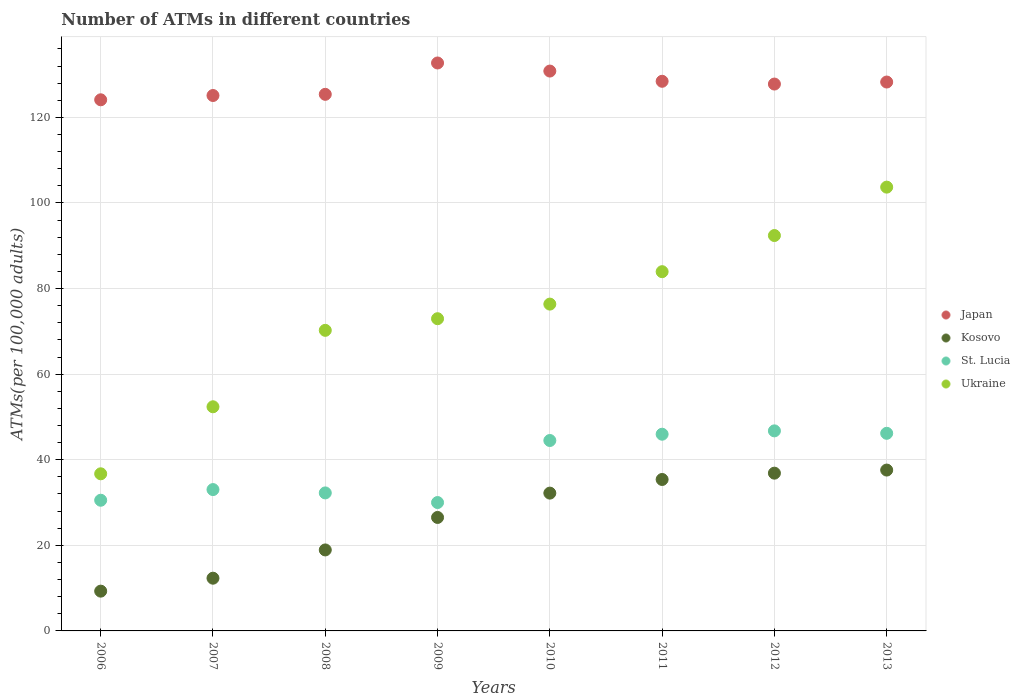How many different coloured dotlines are there?
Offer a very short reply. 4. What is the number of ATMs in Ukraine in 2009?
Provide a succinct answer. 72.96. Across all years, what is the maximum number of ATMs in St. Lucia?
Your answer should be very brief. 46.75. Across all years, what is the minimum number of ATMs in Kosovo?
Your answer should be very brief. 9.29. In which year was the number of ATMs in Kosovo minimum?
Ensure brevity in your answer.  2006. What is the total number of ATMs in Kosovo in the graph?
Your answer should be very brief. 209.1. What is the difference between the number of ATMs in Japan in 2010 and that in 2013?
Provide a short and direct response. 2.56. What is the difference between the number of ATMs in Ukraine in 2006 and the number of ATMs in Kosovo in 2010?
Keep it short and to the point. 4.51. What is the average number of ATMs in St. Lucia per year?
Keep it short and to the point. 38.65. In the year 2006, what is the difference between the number of ATMs in Kosovo and number of ATMs in Japan?
Your answer should be very brief. -114.82. What is the ratio of the number of ATMs in Japan in 2006 to that in 2010?
Provide a short and direct response. 0.95. Is the number of ATMs in Japan in 2008 less than that in 2013?
Ensure brevity in your answer.  Yes. What is the difference between the highest and the second highest number of ATMs in St. Lucia?
Keep it short and to the point. 0.57. What is the difference between the highest and the lowest number of ATMs in Japan?
Give a very brief answer. 8.6. Is the number of ATMs in Ukraine strictly greater than the number of ATMs in Kosovo over the years?
Your response must be concise. Yes. Is the number of ATMs in St. Lucia strictly less than the number of ATMs in Kosovo over the years?
Offer a very short reply. No. What is the difference between two consecutive major ticks on the Y-axis?
Provide a short and direct response. 20. Does the graph contain grids?
Provide a succinct answer. Yes. How many legend labels are there?
Offer a terse response. 4. What is the title of the graph?
Give a very brief answer. Number of ATMs in different countries. Does "Albania" appear as one of the legend labels in the graph?
Make the answer very short. No. What is the label or title of the X-axis?
Give a very brief answer. Years. What is the label or title of the Y-axis?
Offer a very short reply. ATMs(per 100,0 adults). What is the ATMs(per 100,000 adults) of Japan in 2006?
Provide a short and direct response. 124.11. What is the ATMs(per 100,000 adults) in Kosovo in 2006?
Make the answer very short. 9.29. What is the ATMs(per 100,000 adults) in St. Lucia in 2006?
Your answer should be very brief. 30.54. What is the ATMs(per 100,000 adults) of Ukraine in 2006?
Offer a terse response. 36.72. What is the ATMs(per 100,000 adults) of Japan in 2007?
Make the answer very short. 125.11. What is the ATMs(per 100,000 adults) of Kosovo in 2007?
Your response must be concise. 12.32. What is the ATMs(per 100,000 adults) of St. Lucia in 2007?
Keep it short and to the point. 33.03. What is the ATMs(per 100,000 adults) of Ukraine in 2007?
Ensure brevity in your answer.  52.38. What is the ATMs(per 100,000 adults) in Japan in 2008?
Provide a succinct answer. 125.39. What is the ATMs(per 100,000 adults) in Kosovo in 2008?
Your answer should be compact. 18.92. What is the ATMs(per 100,000 adults) in St. Lucia in 2008?
Your response must be concise. 32.25. What is the ATMs(per 100,000 adults) of Ukraine in 2008?
Make the answer very short. 70.24. What is the ATMs(per 100,000 adults) in Japan in 2009?
Your answer should be very brief. 132.71. What is the ATMs(per 100,000 adults) of Kosovo in 2009?
Provide a short and direct response. 26.52. What is the ATMs(per 100,000 adults) in St. Lucia in 2009?
Provide a succinct answer. 30. What is the ATMs(per 100,000 adults) of Ukraine in 2009?
Your answer should be very brief. 72.96. What is the ATMs(per 100,000 adults) in Japan in 2010?
Make the answer very short. 130.82. What is the ATMs(per 100,000 adults) of Kosovo in 2010?
Provide a short and direct response. 32.2. What is the ATMs(per 100,000 adults) of St. Lucia in 2010?
Your response must be concise. 44.5. What is the ATMs(per 100,000 adults) of Ukraine in 2010?
Your answer should be very brief. 76.37. What is the ATMs(per 100,000 adults) of Japan in 2011?
Make the answer very short. 128.44. What is the ATMs(per 100,000 adults) in Kosovo in 2011?
Offer a terse response. 35.39. What is the ATMs(per 100,000 adults) of St. Lucia in 2011?
Your answer should be compact. 45.96. What is the ATMs(per 100,000 adults) of Ukraine in 2011?
Offer a terse response. 83.95. What is the ATMs(per 100,000 adults) in Japan in 2012?
Keep it short and to the point. 127.79. What is the ATMs(per 100,000 adults) of Kosovo in 2012?
Provide a short and direct response. 36.86. What is the ATMs(per 100,000 adults) of St. Lucia in 2012?
Offer a terse response. 46.75. What is the ATMs(per 100,000 adults) of Ukraine in 2012?
Make the answer very short. 92.39. What is the ATMs(per 100,000 adults) in Japan in 2013?
Your answer should be compact. 128.26. What is the ATMs(per 100,000 adults) in Kosovo in 2013?
Ensure brevity in your answer.  37.59. What is the ATMs(per 100,000 adults) in St. Lucia in 2013?
Offer a very short reply. 46.18. What is the ATMs(per 100,000 adults) in Ukraine in 2013?
Your answer should be compact. 103.7. Across all years, what is the maximum ATMs(per 100,000 adults) in Japan?
Offer a terse response. 132.71. Across all years, what is the maximum ATMs(per 100,000 adults) of Kosovo?
Offer a very short reply. 37.59. Across all years, what is the maximum ATMs(per 100,000 adults) in St. Lucia?
Offer a very short reply. 46.75. Across all years, what is the maximum ATMs(per 100,000 adults) in Ukraine?
Offer a very short reply. 103.7. Across all years, what is the minimum ATMs(per 100,000 adults) of Japan?
Ensure brevity in your answer.  124.11. Across all years, what is the minimum ATMs(per 100,000 adults) in Kosovo?
Provide a short and direct response. 9.29. Across all years, what is the minimum ATMs(per 100,000 adults) in St. Lucia?
Keep it short and to the point. 30. Across all years, what is the minimum ATMs(per 100,000 adults) in Ukraine?
Your response must be concise. 36.72. What is the total ATMs(per 100,000 adults) of Japan in the graph?
Give a very brief answer. 1022.63. What is the total ATMs(per 100,000 adults) in Kosovo in the graph?
Keep it short and to the point. 209.1. What is the total ATMs(per 100,000 adults) of St. Lucia in the graph?
Give a very brief answer. 309.2. What is the total ATMs(per 100,000 adults) of Ukraine in the graph?
Make the answer very short. 588.7. What is the difference between the ATMs(per 100,000 adults) of Japan in 2006 and that in 2007?
Keep it short and to the point. -1. What is the difference between the ATMs(per 100,000 adults) of Kosovo in 2006 and that in 2007?
Offer a very short reply. -3.03. What is the difference between the ATMs(per 100,000 adults) of St. Lucia in 2006 and that in 2007?
Provide a succinct answer. -2.49. What is the difference between the ATMs(per 100,000 adults) of Ukraine in 2006 and that in 2007?
Your answer should be compact. -15.66. What is the difference between the ATMs(per 100,000 adults) of Japan in 2006 and that in 2008?
Offer a very short reply. -1.28. What is the difference between the ATMs(per 100,000 adults) of Kosovo in 2006 and that in 2008?
Your answer should be very brief. -9.63. What is the difference between the ATMs(per 100,000 adults) of St. Lucia in 2006 and that in 2008?
Give a very brief answer. -1.71. What is the difference between the ATMs(per 100,000 adults) of Ukraine in 2006 and that in 2008?
Provide a succinct answer. -33.52. What is the difference between the ATMs(per 100,000 adults) in Japan in 2006 and that in 2009?
Make the answer very short. -8.6. What is the difference between the ATMs(per 100,000 adults) in Kosovo in 2006 and that in 2009?
Your answer should be compact. -17.22. What is the difference between the ATMs(per 100,000 adults) of St. Lucia in 2006 and that in 2009?
Your answer should be very brief. 0.54. What is the difference between the ATMs(per 100,000 adults) of Ukraine in 2006 and that in 2009?
Your answer should be compact. -36.24. What is the difference between the ATMs(per 100,000 adults) of Japan in 2006 and that in 2010?
Offer a terse response. -6.71. What is the difference between the ATMs(per 100,000 adults) in Kosovo in 2006 and that in 2010?
Keep it short and to the point. -22.91. What is the difference between the ATMs(per 100,000 adults) of St. Lucia in 2006 and that in 2010?
Offer a terse response. -13.96. What is the difference between the ATMs(per 100,000 adults) in Ukraine in 2006 and that in 2010?
Provide a short and direct response. -39.65. What is the difference between the ATMs(per 100,000 adults) of Japan in 2006 and that in 2011?
Offer a very short reply. -4.33. What is the difference between the ATMs(per 100,000 adults) of Kosovo in 2006 and that in 2011?
Ensure brevity in your answer.  -26.09. What is the difference between the ATMs(per 100,000 adults) of St. Lucia in 2006 and that in 2011?
Give a very brief answer. -15.43. What is the difference between the ATMs(per 100,000 adults) in Ukraine in 2006 and that in 2011?
Offer a terse response. -47.23. What is the difference between the ATMs(per 100,000 adults) in Japan in 2006 and that in 2012?
Offer a terse response. -3.68. What is the difference between the ATMs(per 100,000 adults) of Kosovo in 2006 and that in 2012?
Your answer should be very brief. -27.57. What is the difference between the ATMs(per 100,000 adults) in St. Lucia in 2006 and that in 2012?
Provide a short and direct response. -16.21. What is the difference between the ATMs(per 100,000 adults) of Ukraine in 2006 and that in 2012?
Your answer should be very brief. -55.68. What is the difference between the ATMs(per 100,000 adults) of Japan in 2006 and that in 2013?
Give a very brief answer. -4.15. What is the difference between the ATMs(per 100,000 adults) in Kosovo in 2006 and that in 2013?
Your answer should be compact. -28.29. What is the difference between the ATMs(per 100,000 adults) in St. Lucia in 2006 and that in 2013?
Your answer should be very brief. -15.64. What is the difference between the ATMs(per 100,000 adults) of Ukraine in 2006 and that in 2013?
Your answer should be very brief. -66.99. What is the difference between the ATMs(per 100,000 adults) of Japan in 2007 and that in 2008?
Give a very brief answer. -0.28. What is the difference between the ATMs(per 100,000 adults) of Kosovo in 2007 and that in 2008?
Ensure brevity in your answer.  -6.6. What is the difference between the ATMs(per 100,000 adults) in St. Lucia in 2007 and that in 2008?
Offer a very short reply. 0.78. What is the difference between the ATMs(per 100,000 adults) in Ukraine in 2007 and that in 2008?
Your answer should be compact. -17.86. What is the difference between the ATMs(per 100,000 adults) of Japan in 2007 and that in 2009?
Your answer should be compact. -7.6. What is the difference between the ATMs(per 100,000 adults) of Kosovo in 2007 and that in 2009?
Your answer should be very brief. -14.2. What is the difference between the ATMs(per 100,000 adults) in St. Lucia in 2007 and that in 2009?
Make the answer very short. 3.03. What is the difference between the ATMs(per 100,000 adults) in Ukraine in 2007 and that in 2009?
Ensure brevity in your answer.  -20.58. What is the difference between the ATMs(per 100,000 adults) of Japan in 2007 and that in 2010?
Ensure brevity in your answer.  -5.71. What is the difference between the ATMs(per 100,000 adults) of Kosovo in 2007 and that in 2010?
Your answer should be very brief. -19.88. What is the difference between the ATMs(per 100,000 adults) in St. Lucia in 2007 and that in 2010?
Keep it short and to the point. -11.47. What is the difference between the ATMs(per 100,000 adults) in Ukraine in 2007 and that in 2010?
Give a very brief answer. -23.99. What is the difference between the ATMs(per 100,000 adults) in Japan in 2007 and that in 2011?
Ensure brevity in your answer.  -3.32. What is the difference between the ATMs(per 100,000 adults) in Kosovo in 2007 and that in 2011?
Your response must be concise. -23.07. What is the difference between the ATMs(per 100,000 adults) in St. Lucia in 2007 and that in 2011?
Give a very brief answer. -12.94. What is the difference between the ATMs(per 100,000 adults) in Ukraine in 2007 and that in 2011?
Offer a very short reply. -31.57. What is the difference between the ATMs(per 100,000 adults) of Japan in 2007 and that in 2012?
Your answer should be compact. -2.68. What is the difference between the ATMs(per 100,000 adults) of Kosovo in 2007 and that in 2012?
Offer a terse response. -24.54. What is the difference between the ATMs(per 100,000 adults) in St. Lucia in 2007 and that in 2012?
Offer a very short reply. -13.72. What is the difference between the ATMs(per 100,000 adults) in Ukraine in 2007 and that in 2012?
Keep it short and to the point. -40.02. What is the difference between the ATMs(per 100,000 adults) of Japan in 2007 and that in 2013?
Keep it short and to the point. -3.15. What is the difference between the ATMs(per 100,000 adults) in Kosovo in 2007 and that in 2013?
Your answer should be very brief. -25.27. What is the difference between the ATMs(per 100,000 adults) of St. Lucia in 2007 and that in 2013?
Your response must be concise. -13.15. What is the difference between the ATMs(per 100,000 adults) in Ukraine in 2007 and that in 2013?
Keep it short and to the point. -51.33. What is the difference between the ATMs(per 100,000 adults) of Japan in 2008 and that in 2009?
Provide a succinct answer. -7.32. What is the difference between the ATMs(per 100,000 adults) of Kosovo in 2008 and that in 2009?
Provide a short and direct response. -7.59. What is the difference between the ATMs(per 100,000 adults) in St. Lucia in 2008 and that in 2009?
Offer a terse response. 2.25. What is the difference between the ATMs(per 100,000 adults) of Ukraine in 2008 and that in 2009?
Keep it short and to the point. -2.72. What is the difference between the ATMs(per 100,000 adults) in Japan in 2008 and that in 2010?
Your answer should be compact. -5.44. What is the difference between the ATMs(per 100,000 adults) in Kosovo in 2008 and that in 2010?
Give a very brief answer. -13.28. What is the difference between the ATMs(per 100,000 adults) of St. Lucia in 2008 and that in 2010?
Give a very brief answer. -12.25. What is the difference between the ATMs(per 100,000 adults) of Ukraine in 2008 and that in 2010?
Give a very brief answer. -6.13. What is the difference between the ATMs(per 100,000 adults) of Japan in 2008 and that in 2011?
Your response must be concise. -3.05. What is the difference between the ATMs(per 100,000 adults) in Kosovo in 2008 and that in 2011?
Give a very brief answer. -16.46. What is the difference between the ATMs(per 100,000 adults) in St. Lucia in 2008 and that in 2011?
Provide a short and direct response. -13.72. What is the difference between the ATMs(per 100,000 adults) in Ukraine in 2008 and that in 2011?
Ensure brevity in your answer.  -13.71. What is the difference between the ATMs(per 100,000 adults) of Japan in 2008 and that in 2012?
Provide a succinct answer. -2.4. What is the difference between the ATMs(per 100,000 adults) of Kosovo in 2008 and that in 2012?
Your response must be concise. -17.94. What is the difference between the ATMs(per 100,000 adults) in St. Lucia in 2008 and that in 2012?
Provide a succinct answer. -14.5. What is the difference between the ATMs(per 100,000 adults) of Ukraine in 2008 and that in 2012?
Give a very brief answer. -22.15. What is the difference between the ATMs(per 100,000 adults) in Japan in 2008 and that in 2013?
Ensure brevity in your answer.  -2.87. What is the difference between the ATMs(per 100,000 adults) of Kosovo in 2008 and that in 2013?
Your answer should be compact. -18.66. What is the difference between the ATMs(per 100,000 adults) in St. Lucia in 2008 and that in 2013?
Your answer should be compact. -13.93. What is the difference between the ATMs(per 100,000 adults) in Ukraine in 2008 and that in 2013?
Make the answer very short. -33.46. What is the difference between the ATMs(per 100,000 adults) in Japan in 2009 and that in 2010?
Provide a succinct answer. 1.89. What is the difference between the ATMs(per 100,000 adults) in Kosovo in 2009 and that in 2010?
Give a very brief answer. -5.68. What is the difference between the ATMs(per 100,000 adults) in St. Lucia in 2009 and that in 2010?
Keep it short and to the point. -14.5. What is the difference between the ATMs(per 100,000 adults) in Ukraine in 2009 and that in 2010?
Keep it short and to the point. -3.41. What is the difference between the ATMs(per 100,000 adults) in Japan in 2009 and that in 2011?
Ensure brevity in your answer.  4.28. What is the difference between the ATMs(per 100,000 adults) in Kosovo in 2009 and that in 2011?
Your response must be concise. -8.87. What is the difference between the ATMs(per 100,000 adults) in St. Lucia in 2009 and that in 2011?
Your answer should be compact. -15.96. What is the difference between the ATMs(per 100,000 adults) in Ukraine in 2009 and that in 2011?
Your answer should be very brief. -10.99. What is the difference between the ATMs(per 100,000 adults) of Japan in 2009 and that in 2012?
Ensure brevity in your answer.  4.92. What is the difference between the ATMs(per 100,000 adults) of Kosovo in 2009 and that in 2012?
Offer a very short reply. -10.35. What is the difference between the ATMs(per 100,000 adults) of St. Lucia in 2009 and that in 2012?
Your response must be concise. -16.75. What is the difference between the ATMs(per 100,000 adults) of Ukraine in 2009 and that in 2012?
Provide a short and direct response. -19.44. What is the difference between the ATMs(per 100,000 adults) of Japan in 2009 and that in 2013?
Provide a succinct answer. 4.45. What is the difference between the ATMs(per 100,000 adults) of Kosovo in 2009 and that in 2013?
Offer a very short reply. -11.07. What is the difference between the ATMs(per 100,000 adults) in St. Lucia in 2009 and that in 2013?
Keep it short and to the point. -16.18. What is the difference between the ATMs(per 100,000 adults) of Ukraine in 2009 and that in 2013?
Offer a terse response. -30.75. What is the difference between the ATMs(per 100,000 adults) of Japan in 2010 and that in 2011?
Ensure brevity in your answer.  2.39. What is the difference between the ATMs(per 100,000 adults) of Kosovo in 2010 and that in 2011?
Ensure brevity in your answer.  -3.19. What is the difference between the ATMs(per 100,000 adults) of St. Lucia in 2010 and that in 2011?
Offer a very short reply. -1.47. What is the difference between the ATMs(per 100,000 adults) of Ukraine in 2010 and that in 2011?
Make the answer very short. -7.58. What is the difference between the ATMs(per 100,000 adults) in Japan in 2010 and that in 2012?
Ensure brevity in your answer.  3.04. What is the difference between the ATMs(per 100,000 adults) in Kosovo in 2010 and that in 2012?
Your response must be concise. -4.66. What is the difference between the ATMs(per 100,000 adults) in St. Lucia in 2010 and that in 2012?
Provide a succinct answer. -2.25. What is the difference between the ATMs(per 100,000 adults) of Ukraine in 2010 and that in 2012?
Your answer should be very brief. -16.02. What is the difference between the ATMs(per 100,000 adults) of Japan in 2010 and that in 2013?
Your response must be concise. 2.56. What is the difference between the ATMs(per 100,000 adults) of Kosovo in 2010 and that in 2013?
Give a very brief answer. -5.39. What is the difference between the ATMs(per 100,000 adults) in St. Lucia in 2010 and that in 2013?
Ensure brevity in your answer.  -1.68. What is the difference between the ATMs(per 100,000 adults) of Ukraine in 2010 and that in 2013?
Your answer should be very brief. -27.33. What is the difference between the ATMs(per 100,000 adults) of Japan in 2011 and that in 2012?
Offer a very short reply. 0.65. What is the difference between the ATMs(per 100,000 adults) of Kosovo in 2011 and that in 2012?
Your response must be concise. -1.48. What is the difference between the ATMs(per 100,000 adults) in St. Lucia in 2011 and that in 2012?
Your answer should be very brief. -0.78. What is the difference between the ATMs(per 100,000 adults) of Ukraine in 2011 and that in 2012?
Give a very brief answer. -8.45. What is the difference between the ATMs(per 100,000 adults) in Japan in 2011 and that in 2013?
Offer a terse response. 0.17. What is the difference between the ATMs(per 100,000 adults) in Kosovo in 2011 and that in 2013?
Your answer should be compact. -2.2. What is the difference between the ATMs(per 100,000 adults) of St. Lucia in 2011 and that in 2013?
Provide a succinct answer. -0.21. What is the difference between the ATMs(per 100,000 adults) in Ukraine in 2011 and that in 2013?
Keep it short and to the point. -19.76. What is the difference between the ATMs(per 100,000 adults) of Japan in 2012 and that in 2013?
Provide a succinct answer. -0.47. What is the difference between the ATMs(per 100,000 adults) in Kosovo in 2012 and that in 2013?
Provide a succinct answer. -0.72. What is the difference between the ATMs(per 100,000 adults) in St. Lucia in 2012 and that in 2013?
Offer a terse response. 0.57. What is the difference between the ATMs(per 100,000 adults) in Ukraine in 2012 and that in 2013?
Your answer should be very brief. -11.31. What is the difference between the ATMs(per 100,000 adults) in Japan in 2006 and the ATMs(per 100,000 adults) in Kosovo in 2007?
Your answer should be compact. 111.79. What is the difference between the ATMs(per 100,000 adults) of Japan in 2006 and the ATMs(per 100,000 adults) of St. Lucia in 2007?
Provide a succinct answer. 91.08. What is the difference between the ATMs(per 100,000 adults) of Japan in 2006 and the ATMs(per 100,000 adults) of Ukraine in 2007?
Provide a succinct answer. 71.73. What is the difference between the ATMs(per 100,000 adults) in Kosovo in 2006 and the ATMs(per 100,000 adults) in St. Lucia in 2007?
Your answer should be compact. -23.73. What is the difference between the ATMs(per 100,000 adults) in Kosovo in 2006 and the ATMs(per 100,000 adults) in Ukraine in 2007?
Ensure brevity in your answer.  -43.08. What is the difference between the ATMs(per 100,000 adults) in St. Lucia in 2006 and the ATMs(per 100,000 adults) in Ukraine in 2007?
Keep it short and to the point. -21.84. What is the difference between the ATMs(per 100,000 adults) of Japan in 2006 and the ATMs(per 100,000 adults) of Kosovo in 2008?
Make the answer very short. 105.19. What is the difference between the ATMs(per 100,000 adults) of Japan in 2006 and the ATMs(per 100,000 adults) of St. Lucia in 2008?
Your answer should be compact. 91.86. What is the difference between the ATMs(per 100,000 adults) in Japan in 2006 and the ATMs(per 100,000 adults) in Ukraine in 2008?
Your answer should be very brief. 53.87. What is the difference between the ATMs(per 100,000 adults) in Kosovo in 2006 and the ATMs(per 100,000 adults) in St. Lucia in 2008?
Offer a very short reply. -22.95. What is the difference between the ATMs(per 100,000 adults) of Kosovo in 2006 and the ATMs(per 100,000 adults) of Ukraine in 2008?
Provide a succinct answer. -60.94. What is the difference between the ATMs(per 100,000 adults) of St. Lucia in 2006 and the ATMs(per 100,000 adults) of Ukraine in 2008?
Offer a very short reply. -39.7. What is the difference between the ATMs(per 100,000 adults) in Japan in 2006 and the ATMs(per 100,000 adults) in Kosovo in 2009?
Your answer should be compact. 97.59. What is the difference between the ATMs(per 100,000 adults) of Japan in 2006 and the ATMs(per 100,000 adults) of St. Lucia in 2009?
Your answer should be very brief. 94.11. What is the difference between the ATMs(per 100,000 adults) of Japan in 2006 and the ATMs(per 100,000 adults) of Ukraine in 2009?
Offer a very short reply. 51.15. What is the difference between the ATMs(per 100,000 adults) of Kosovo in 2006 and the ATMs(per 100,000 adults) of St. Lucia in 2009?
Give a very brief answer. -20.7. What is the difference between the ATMs(per 100,000 adults) of Kosovo in 2006 and the ATMs(per 100,000 adults) of Ukraine in 2009?
Provide a succinct answer. -63.66. What is the difference between the ATMs(per 100,000 adults) of St. Lucia in 2006 and the ATMs(per 100,000 adults) of Ukraine in 2009?
Your answer should be very brief. -42.42. What is the difference between the ATMs(per 100,000 adults) of Japan in 2006 and the ATMs(per 100,000 adults) of Kosovo in 2010?
Provide a short and direct response. 91.91. What is the difference between the ATMs(per 100,000 adults) in Japan in 2006 and the ATMs(per 100,000 adults) in St. Lucia in 2010?
Your answer should be very brief. 79.61. What is the difference between the ATMs(per 100,000 adults) in Japan in 2006 and the ATMs(per 100,000 adults) in Ukraine in 2010?
Give a very brief answer. 47.74. What is the difference between the ATMs(per 100,000 adults) of Kosovo in 2006 and the ATMs(per 100,000 adults) of St. Lucia in 2010?
Provide a succinct answer. -35.2. What is the difference between the ATMs(per 100,000 adults) in Kosovo in 2006 and the ATMs(per 100,000 adults) in Ukraine in 2010?
Provide a succinct answer. -67.07. What is the difference between the ATMs(per 100,000 adults) of St. Lucia in 2006 and the ATMs(per 100,000 adults) of Ukraine in 2010?
Your response must be concise. -45.83. What is the difference between the ATMs(per 100,000 adults) of Japan in 2006 and the ATMs(per 100,000 adults) of Kosovo in 2011?
Offer a terse response. 88.72. What is the difference between the ATMs(per 100,000 adults) in Japan in 2006 and the ATMs(per 100,000 adults) in St. Lucia in 2011?
Provide a short and direct response. 78.15. What is the difference between the ATMs(per 100,000 adults) in Japan in 2006 and the ATMs(per 100,000 adults) in Ukraine in 2011?
Your answer should be very brief. 40.16. What is the difference between the ATMs(per 100,000 adults) in Kosovo in 2006 and the ATMs(per 100,000 adults) in St. Lucia in 2011?
Make the answer very short. -36.67. What is the difference between the ATMs(per 100,000 adults) in Kosovo in 2006 and the ATMs(per 100,000 adults) in Ukraine in 2011?
Make the answer very short. -74.65. What is the difference between the ATMs(per 100,000 adults) in St. Lucia in 2006 and the ATMs(per 100,000 adults) in Ukraine in 2011?
Offer a terse response. -53.41. What is the difference between the ATMs(per 100,000 adults) in Japan in 2006 and the ATMs(per 100,000 adults) in Kosovo in 2012?
Your response must be concise. 87.25. What is the difference between the ATMs(per 100,000 adults) in Japan in 2006 and the ATMs(per 100,000 adults) in St. Lucia in 2012?
Provide a short and direct response. 77.36. What is the difference between the ATMs(per 100,000 adults) in Japan in 2006 and the ATMs(per 100,000 adults) in Ukraine in 2012?
Provide a short and direct response. 31.72. What is the difference between the ATMs(per 100,000 adults) in Kosovo in 2006 and the ATMs(per 100,000 adults) in St. Lucia in 2012?
Offer a terse response. -37.45. What is the difference between the ATMs(per 100,000 adults) of Kosovo in 2006 and the ATMs(per 100,000 adults) of Ukraine in 2012?
Offer a terse response. -83.1. What is the difference between the ATMs(per 100,000 adults) of St. Lucia in 2006 and the ATMs(per 100,000 adults) of Ukraine in 2012?
Provide a succinct answer. -61.86. What is the difference between the ATMs(per 100,000 adults) in Japan in 2006 and the ATMs(per 100,000 adults) in Kosovo in 2013?
Offer a very short reply. 86.52. What is the difference between the ATMs(per 100,000 adults) in Japan in 2006 and the ATMs(per 100,000 adults) in St. Lucia in 2013?
Provide a succinct answer. 77.93. What is the difference between the ATMs(per 100,000 adults) in Japan in 2006 and the ATMs(per 100,000 adults) in Ukraine in 2013?
Your answer should be very brief. 20.41. What is the difference between the ATMs(per 100,000 adults) in Kosovo in 2006 and the ATMs(per 100,000 adults) in St. Lucia in 2013?
Make the answer very short. -36.88. What is the difference between the ATMs(per 100,000 adults) in Kosovo in 2006 and the ATMs(per 100,000 adults) in Ukraine in 2013?
Offer a very short reply. -94.41. What is the difference between the ATMs(per 100,000 adults) of St. Lucia in 2006 and the ATMs(per 100,000 adults) of Ukraine in 2013?
Provide a succinct answer. -73.16. What is the difference between the ATMs(per 100,000 adults) of Japan in 2007 and the ATMs(per 100,000 adults) of Kosovo in 2008?
Provide a succinct answer. 106.19. What is the difference between the ATMs(per 100,000 adults) of Japan in 2007 and the ATMs(per 100,000 adults) of St. Lucia in 2008?
Your response must be concise. 92.86. What is the difference between the ATMs(per 100,000 adults) of Japan in 2007 and the ATMs(per 100,000 adults) of Ukraine in 2008?
Make the answer very short. 54.87. What is the difference between the ATMs(per 100,000 adults) in Kosovo in 2007 and the ATMs(per 100,000 adults) in St. Lucia in 2008?
Your answer should be very brief. -19.93. What is the difference between the ATMs(per 100,000 adults) of Kosovo in 2007 and the ATMs(per 100,000 adults) of Ukraine in 2008?
Give a very brief answer. -57.92. What is the difference between the ATMs(per 100,000 adults) of St. Lucia in 2007 and the ATMs(per 100,000 adults) of Ukraine in 2008?
Your response must be concise. -37.21. What is the difference between the ATMs(per 100,000 adults) of Japan in 2007 and the ATMs(per 100,000 adults) of Kosovo in 2009?
Ensure brevity in your answer.  98.6. What is the difference between the ATMs(per 100,000 adults) of Japan in 2007 and the ATMs(per 100,000 adults) of St. Lucia in 2009?
Your answer should be compact. 95.11. What is the difference between the ATMs(per 100,000 adults) of Japan in 2007 and the ATMs(per 100,000 adults) of Ukraine in 2009?
Make the answer very short. 52.16. What is the difference between the ATMs(per 100,000 adults) in Kosovo in 2007 and the ATMs(per 100,000 adults) in St. Lucia in 2009?
Provide a succinct answer. -17.68. What is the difference between the ATMs(per 100,000 adults) of Kosovo in 2007 and the ATMs(per 100,000 adults) of Ukraine in 2009?
Ensure brevity in your answer.  -60.64. What is the difference between the ATMs(per 100,000 adults) of St. Lucia in 2007 and the ATMs(per 100,000 adults) of Ukraine in 2009?
Make the answer very short. -39.93. What is the difference between the ATMs(per 100,000 adults) in Japan in 2007 and the ATMs(per 100,000 adults) in Kosovo in 2010?
Keep it short and to the point. 92.91. What is the difference between the ATMs(per 100,000 adults) of Japan in 2007 and the ATMs(per 100,000 adults) of St. Lucia in 2010?
Give a very brief answer. 80.62. What is the difference between the ATMs(per 100,000 adults) of Japan in 2007 and the ATMs(per 100,000 adults) of Ukraine in 2010?
Ensure brevity in your answer.  48.74. What is the difference between the ATMs(per 100,000 adults) in Kosovo in 2007 and the ATMs(per 100,000 adults) in St. Lucia in 2010?
Ensure brevity in your answer.  -32.18. What is the difference between the ATMs(per 100,000 adults) of Kosovo in 2007 and the ATMs(per 100,000 adults) of Ukraine in 2010?
Your response must be concise. -64.05. What is the difference between the ATMs(per 100,000 adults) in St. Lucia in 2007 and the ATMs(per 100,000 adults) in Ukraine in 2010?
Ensure brevity in your answer.  -43.34. What is the difference between the ATMs(per 100,000 adults) in Japan in 2007 and the ATMs(per 100,000 adults) in Kosovo in 2011?
Your response must be concise. 89.72. What is the difference between the ATMs(per 100,000 adults) of Japan in 2007 and the ATMs(per 100,000 adults) of St. Lucia in 2011?
Offer a very short reply. 79.15. What is the difference between the ATMs(per 100,000 adults) in Japan in 2007 and the ATMs(per 100,000 adults) in Ukraine in 2011?
Provide a short and direct response. 41.17. What is the difference between the ATMs(per 100,000 adults) of Kosovo in 2007 and the ATMs(per 100,000 adults) of St. Lucia in 2011?
Provide a short and direct response. -33.64. What is the difference between the ATMs(per 100,000 adults) of Kosovo in 2007 and the ATMs(per 100,000 adults) of Ukraine in 2011?
Your answer should be compact. -71.63. What is the difference between the ATMs(per 100,000 adults) of St. Lucia in 2007 and the ATMs(per 100,000 adults) of Ukraine in 2011?
Ensure brevity in your answer.  -50.92. What is the difference between the ATMs(per 100,000 adults) of Japan in 2007 and the ATMs(per 100,000 adults) of Kosovo in 2012?
Offer a very short reply. 88.25. What is the difference between the ATMs(per 100,000 adults) in Japan in 2007 and the ATMs(per 100,000 adults) in St. Lucia in 2012?
Your answer should be compact. 78.37. What is the difference between the ATMs(per 100,000 adults) of Japan in 2007 and the ATMs(per 100,000 adults) of Ukraine in 2012?
Keep it short and to the point. 32.72. What is the difference between the ATMs(per 100,000 adults) in Kosovo in 2007 and the ATMs(per 100,000 adults) in St. Lucia in 2012?
Provide a short and direct response. -34.43. What is the difference between the ATMs(per 100,000 adults) of Kosovo in 2007 and the ATMs(per 100,000 adults) of Ukraine in 2012?
Provide a succinct answer. -80.07. What is the difference between the ATMs(per 100,000 adults) of St. Lucia in 2007 and the ATMs(per 100,000 adults) of Ukraine in 2012?
Give a very brief answer. -59.37. What is the difference between the ATMs(per 100,000 adults) in Japan in 2007 and the ATMs(per 100,000 adults) in Kosovo in 2013?
Provide a short and direct response. 87.52. What is the difference between the ATMs(per 100,000 adults) in Japan in 2007 and the ATMs(per 100,000 adults) in St. Lucia in 2013?
Make the answer very short. 78.94. What is the difference between the ATMs(per 100,000 adults) of Japan in 2007 and the ATMs(per 100,000 adults) of Ukraine in 2013?
Provide a succinct answer. 21.41. What is the difference between the ATMs(per 100,000 adults) in Kosovo in 2007 and the ATMs(per 100,000 adults) in St. Lucia in 2013?
Ensure brevity in your answer.  -33.86. What is the difference between the ATMs(per 100,000 adults) in Kosovo in 2007 and the ATMs(per 100,000 adults) in Ukraine in 2013?
Keep it short and to the point. -91.38. What is the difference between the ATMs(per 100,000 adults) in St. Lucia in 2007 and the ATMs(per 100,000 adults) in Ukraine in 2013?
Make the answer very short. -70.67. What is the difference between the ATMs(per 100,000 adults) of Japan in 2008 and the ATMs(per 100,000 adults) of Kosovo in 2009?
Keep it short and to the point. 98.87. What is the difference between the ATMs(per 100,000 adults) of Japan in 2008 and the ATMs(per 100,000 adults) of St. Lucia in 2009?
Your answer should be compact. 95.39. What is the difference between the ATMs(per 100,000 adults) in Japan in 2008 and the ATMs(per 100,000 adults) in Ukraine in 2009?
Ensure brevity in your answer.  52.43. What is the difference between the ATMs(per 100,000 adults) in Kosovo in 2008 and the ATMs(per 100,000 adults) in St. Lucia in 2009?
Give a very brief answer. -11.08. What is the difference between the ATMs(per 100,000 adults) of Kosovo in 2008 and the ATMs(per 100,000 adults) of Ukraine in 2009?
Ensure brevity in your answer.  -54.03. What is the difference between the ATMs(per 100,000 adults) of St. Lucia in 2008 and the ATMs(per 100,000 adults) of Ukraine in 2009?
Ensure brevity in your answer.  -40.71. What is the difference between the ATMs(per 100,000 adults) in Japan in 2008 and the ATMs(per 100,000 adults) in Kosovo in 2010?
Your answer should be very brief. 93.19. What is the difference between the ATMs(per 100,000 adults) in Japan in 2008 and the ATMs(per 100,000 adults) in St. Lucia in 2010?
Ensure brevity in your answer.  80.89. What is the difference between the ATMs(per 100,000 adults) of Japan in 2008 and the ATMs(per 100,000 adults) of Ukraine in 2010?
Give a very brief answer. 49.02. What is the difference between the ATMs(per 100,000 adults) in Kosovo in 2008 and the ATMs(per 100,000 adults) in St. Lucia in 2010?
Give a very brief answer. -25.57. What is the difference between the ATMs(per 100,000 adults) in Kosovo in 2008 and the ATMs(per 100,000 adults) in Ukraine in 2010?
Your response must be concise. -57.44. What is the difference between the ATMs(per 100,000 adults) in St. Lucia in 2008 and the ATMs(per 100,000 adults) in Ukraine in 2010?
Your answer should be compact. -44.12. What is the difference between the ATMs(per 100,000 adults) of Japan in 2008 and the ATMs(per 100,000 adults) of Kosovo in 2011?
Offer a very short reply. 90. What is the difference between the ATMs(per 100,000 adults) in Japan in 2008 and the ATMs(per 100,000 adults) in St. Lucia in 2011?
Your answer should be very brief. 79.42. What is the difference between the ATMs(per 100,000 adults) of Japan in 2008 and the ATMs(per 100,000 adults) of Ukraine in 2011?
Provide a short and direct response. 41.44. What is the difference between the ATMs(per 100,000 adults) of Kosovo in 2008 and the ATMs(per 100,000 adults) of St. Lucia in 2011?
Keep it short and to the point. -27.04. What is the difference between the ATMs(per 100,000 adults) of Kosovo in 2008 and the ATMs(per 100,000 adults) of Ukraine in 2011?
Provide a succinct answer. -65.02. What is the difference between the ATMs(per 100,000 adults) of St. Lucia in 2008 and the ATMs(per 100,000 adults) of Ukraine in 2011?
Provide a short and direct response. -51.7. What is the difference between the ATMs(per 100,000 adults) in Japan in 2008 and the ATMs(per 100,000 adults) in Kosovo in 2012?
Offer a terse response. 88.52. What is the difference between the ATMs(per 100,000 adults) in Japan in 2008 and the ATMs(per 100,000 adults) in St. Lucia in 2012?
Offer a terse response. 78.64. What is the difference between the ATMs(per 100,000 adults) in Japan in 2008 and the ATMs(per 100,000 adults) in Ukraine in 2012?
Give a very brief answer. 33. What is the difference between the ATMs(per 100,000 adults) of Kosovo in 2008 and the ATMs(per 100,000 adults) of St. Lucia in 2012?
Keep it short and to the point. -27.82. What is the difference between the ATMs(per 100,000 adults) in Kosovo in 2008 and the ATMs(per 100,000 adults) in Ukraine in 2012?
Offer a terse response. -73.47. What is the difference between the ATMs(per 100,000 adults) of St. Lucia in 2008 and the ATMs(per 100,000 adults) of Ukraine in 2012?
Your answer should be compact. -60.14. What is the difference between the ATMs(per 100,000 adults) in Japan in 2008 and the ATMs(per 100,000 adults) in Kosovo in 2013?
Make the answer very short. 87.8. What is the difference between the ATMs(per 100,000 adults) of Japan in 2008 and the ATMs(per 100,000 adults) of St. Lucia in 2013?
Offer a terse response. 79.21. What is the difference between the ATMs(per 100,000 adults) in Japan in 2008 and the ATMs(per 100,000 adults) in Ukraine in 2013?
Make the answer very short. 21.69. What is the difference between the ATMs(per 100,000 adults) of Kosovo in 2008 and the ATMs(per 100,000 adults) of St. Lucia in 2013?
Give a very brief answer. -27.25. What is the difference between the ATMs(per 100,000 adults) in Kosovo in 2008 and the ATMs(per 100,000 adults) in Ukraine in 2013?
Your answer should be very brief. -84.78. What is the difference between the ATMs(per 100,000 adults) of St. Lucia in 2008 and the ATMs(per 100,000 adults) of Ukraine in 2013?
Ensure brevity in your answer.  -71.45. What is the difference between the ATMs(per 100,000 adults) in Japan in 2009 and the ATMs(per 100,000 adults) in Kosovo in 2010?
Your answer should be very brief. 100.51. What is the difference between the ATMs(per 100,000 adults) in Japan in 2009 and the ATMs(per 100,000 adults) in St. Lucia in 2010?
Keep it short and to the point. 88.22. What is the difference between the ATMs(per 100,000 adults) of Japan in 2009 and the ATMs(per 100,000 adults) of Ukraine in 2010?
Your answer should be compact. 56.34. What is the difference between the ATMs(per 100,000 adults) in Kosovo in 2009 and the ATMs(per 100,000 adults) in St. Lucia in 2010?
Offer a very short reply. -17.98. What is the difference between the ATMs(per 100,000 adults) of Kosovo in 2009 and the ATMs(per 100,000 adults) of Ukraine in 2010?
Ensure brevity in your answer.  -49.85. What is the difference between the ATMs(per 100,000 adults) in St. Lucia in 2009 and the ATMs(per 100,000 adults) in Ukraine in 2010?
Your answer should be very brief. -46.37. What is the difference between the ATMs(per 100,000 adults) of Japan in 2009 and the ATMs(per 100,000 adults) of Kosovo in 2011?
Provide a succinct answer. 97.32. What is the difference between the ATMs(per 100,000 adults) of Japan in 2009 and the ATMs(per 100,000 adults) of St. Lucia in 2011?
Offer a terse response. 86.75. What is the difference between the ATMs(per 100,000 adults) of Japan in 2009 and the ATMs(per 100,000 adults) of Ukraine in 2011?
Keep it short and to the point. 48.77. What is the difference between the ATMs(per 100,000 adults) in Kosovo in 2009 and the ATMs(per 100,000 adults) in St. Lucia in 2011?
Ensure brevity in your answer.  -19.45. What is the difference between the ATMs(per 100,000 adults) in Kosovo in 2009 and the ATMs(per 100,000 adults) in Ukraine in 2011?
Your answer should be very brief. -57.43. What is the difference between the ATMs(per 100,000 adults) of St. Lucia in 2009 and the ATMs(per 100,000 adults) of Ukraine in 2011?
Provide a succinct answer. -53.95. What is the difference between the ATMs(per 100,000 adults) in Japan in 2009 and the ATMs(per 100,000 adults) in Kosovo in 2012?
Your response must be concise. 95.85. What is the difference between the ATMs(per 100,000 adults) of Japan in 2009 and the ATMs(per 100,000 adults) of St. Lucia in 2012?
Your answer should be very brief. 85.97. What is the difference between the ATMs(per 100,000 adults) of Japan in 2009 and the ATMs(per 100,000 adults) of Ukraine in 2012?
Offer a very short reply. 40.32. What is the difference between the ATMs(per 100,000 adults) of Kosovo in 2009 and the ATMs(per 100,000 adults) of St. Lucia in 2012?
Your answer should be compact. -20.23. What is the difference between the ATMs(per 100,000 adults) of Kosovo in 2009 and the ATMs(per 100,000 adults) of Ukraine in 2012?
Make the answer very short. -65.88. What is the difference between the ATMs(per 100,000 adults) in St. Lucia in 2009 and the ATMs(per 100,000 adults) in Ukraine in 2012?
Provide a short and direct response. -62.39. What is the difference between the ATMs(per 100,000 adults) in Japan in 2009 and the ATMs(per 100,000 adults) in Kosovo in 2013?
Make the answer very short. 95.12. What is the difference between the ATMs(per 100,000 adults) in Japan in 2009 and the ATMs(per 100,000 adults) in St. Lucia in 2013?
Make the answer very short. 86.54. What is the difference between the ATMs(per 100,000 adults) in Japan in 2009 and the ATMs(per 100,000 adults) in Ukraine in 2013?
Provide a short and direct response. 29.01. What is the difference between the ATMs(per 100,000 adults) in Kosovo in 2009 and the ATMs(per 100,000 adults) in St. Lucia in 2013?
Your answer should be very brief. -19.66. What is the difference between the ATMs(per 100,000 adults) of Kosovo in 2009 and the ATMs(per 100,000 adults) of Ukraine in 2013?
Your answer should be compact. -77.19. What is the difference between the ATMs(per 100,000 adults) of St. Lucia in 2009 and the ATMs(per 100,000 adults) of Ukraine in 2013?
Provide a succinct answer. -73.7. What is the difference between the ATMs(per 100,000 adults) in Japan in 2010 and the ATMs(per 100,000 adults) in Kosovo in 2011?
Your response must be concise. 95.44. What is the difference between the ATMs(per 100,000 adults) of Japan in 2010 and the ATMs(per 100,000 adults) of St. Lucia in 2011?
Provide a short and direct response. 84.86. What is the difference between the ATMs(per 100,000 adults) of Japan in 2010 and the ATMs(per 100,000 adults) of Ukraine in 2011?
Offer a very short reply. 46.88. What is the difference between the ATMs(per 100,000 adults) of Kosovo in 2010 and the ATMs(per 100,000 adults) of St. Lucia in 2011?
Provide a succinct answer. -13.76. What is the difference between the ATMs(per 100,000 adults) of Kosovo in 2010 and the ATMs(per 100,000 adults) of Ukraine in 2011?
Offer a terse response. -51.74. What is the difference between the ATMs(per 100,000 adults) of St. Lucia in 2010 and the ATMs(per 100,000 adults) of Ukraine in 2011?
Your answer should be compact. -39.45. What is the difference between the ATMs(per 100,000 adults) of Japan in 2010 and the ATMs(per 100,000 adults) of Kosovo in 2012?
Keep it short and to the point. 93.96. What is the difference between the ATMs(per 100,000 adults) in Japan in 2010 and the ATMs(per 100,000 adults) in St. Lucia in 2012?
Give a very brief answer. 84.08. What is the difference between the ATMs(per 100,000 adults) of Japan in 2010 and the ATMs(per 100,000 adults) of Ukraine in 2012?
Give a very brief answer. 38.43. What is the difference between the ATMs(per 100,000 adults) in Kosovo in 2010 and the ATMs(per 100,000 adults) in St. Lucia in 2012?
Offer a very short reply. -14.55. What is the difference between the ATMs(per 100,000 adults) of Kosovo in 2010 and the ATMs(per 100,000 adults) of Ukraine in 2012?
Make the answer very short. -60.19. What is the difference between the ATMs(per 100,000 adults) in St. Lucia in 2010 and the ATMs(per 100,000 adults) in Ukraine in 2012?
Provide a succinct answer. -47.9. What is the difference between the ATMs(per 100,000 adults) in Japan in 2010 and the ATMs(per 100,000 adults) in Kosovo in 2013?
Ensure brevity in your answer.  93.24. What is the difference between the ATMs(per 100,000 adults) in Japan in 2010 and the ATMs(per 100,000 adults) in St. Lucia in 2013?
Keep it short and to the point. 84.65. What is the difference between the ATMs(per 100,000 adults) of Japan in 2010 and the ATMs(per 100,000 adults) of Ukraine in 2013?
Make the answer very short. 27.12. What is the difference between the ATMs(per 100,000 adults) of Kosovo in 2010 and the ATMs(per 100,000 adults) of St. Lucia in 2013?
Your response must be concise. -13.98. What is the difference between the ATMs(per 100,000 adults) in Kosovo in 2010 and the ATMs(per 100,000 adults) in Ukraine in 2013?
Your answer should be very brief. -71.5. What is the difference between the ATMs(per 100,000 adults) in St. Lucia in 2010 and the ATMs(per 100,000 adults) in Ukraine in 2013?
Provide a short and direct response. -59.21. What is the difference between the ATMs(per 100,000 adults) in Japan in 2011 and the ATMs(per 100,000 adults) in Kosovo in 2012?
Your response must be concise. 91.57. What is the difference between the ATMs(per 100,000 adults) in Japan in 2011 and the ATMs(per 100,000 adults) in St. Lucia in 2012?
Keep it short and to the point. 81.69. What is the difference between the ATMs(per 100,000 adults) of Japan in 2011 and the ATMs(per 100,000 adults) of Ukraine in 2012?
Offer a very short reply. 36.04. What is the difference between the ATMs(per 100,000 adults) in Kosovo in 2011 and the ATMs(per 100,000 adults) in St. Lucia in 2012?
Provide a succinct answer. -11.36. What is the difference between the ATMs(per 100,000 adults) in Kosovo in 2011 and the ATMs(per 100,000 adults) in Ukraine in 2012?
Provide a succinct answer. -57. What is the difference between the ATMs(per 100,000 adults) of St. Lucia in 2011 and the ATMs(per 100,000 adults) of Ukraine in 2012?
Offer a very short reply. -46.43. What is the difference between the ATMs(per 100,000 adults) of Japan in 2011 and the ATMs(per 100,000 adults) of Kosovo in 2013?
Provide a short and direct response. 90.85. What is the difference between the ATMs(per 100,000 adults) of Japan in 2011 and the ATMs(per 100,000 adults) of St. Lucia in 2013?
Provide a short and direct response. 82.26. What is the difference between the ATMs(per 100,000 adults) in Japan in 2011 and the ATMs(per 100,000 adults) in Ukraine in 2013?
Offer a very short reply. 24.73. What is the difference between the ATMs(per 100,000 adults) of Kosovo in 2011 and the ATMs(per 100,000 adults) of St. Lucia in 2013?
Ensure brevity in your answer.  -10.79. What is the difference between the ATMs(per 100,000 adults) of Kosovo in 2011 and the ATMs(per 100,000 adults) of Ukraine in 2013?
Your answer should be compact. -68.31. What is the difference between the ATMs(per 100,000 adults) in St. Lucia in 2011 and the ATMs(per 100,000 adults) in Ukraine in 2013?
Offer a terse response. -57.74. What is the difference between the ATMs(per 100,000 adults) in Japan in 2012 and the ATMs(per 100,000 adults) in Kosovo in 2013?
Your answer should be very brief. 90.2. What is the difference between the ATMs(per 100,000 adults) of Japan in 2012 and the ATMs(per 100,000 adults) of St. Lucia in 2013?
Make the answer very short. 81.61. What is the difference between the ATMs(per 100,000 adults) in Japan in 2012 and the ATMs(per 100,000 adults) in Ukraine in 2013?
Ensure brevity in your answer.  24.09. What is the difference between the ATMs(per 100,000 adults) of Kosovo in 2012 and the ATMs(per 100,000 adults) of St. Lucia in 2013?
Your response must be concise. -9.31. What is the difference between the ATMs(per 100,000 adults) of Kosovo in 2012 and the ATMs(per 100,000 adults) of Ukraine in 2013?
Your answer should be very brief. -66.84. What is the difference between the ATMs(per 100,000 adults) in St. Lucia in 2012 and the ATMs(per 100,000 adults) in Ukraine in 2013?
Keep it short and to the point. -56.95. What is the average ATMs(per 100,000 adults) of Japan per year?
Offer a very short reply. 127.83. What is the average ATMs(per 100,000 adults) of Kosovo per year?
Offer a very short reply. 26.14. What is the average ATMs(per 100,000 adults) in St. Lucia per year?
Provide a succinct answer. 38.65. What is the average ATMs(per 100,000 adults) of Ukraine per year?
Offer a terse response. 73.59. In the year 2006, what is the difference between the ATMs(per 100,000 adults) of Japan and ATMs(per 100,000 adults) of Kosovo?
Your answer should be very brief. 114.82. In the year 2006, what is the difference between the ATMs(per 100,000 adults) in Japan and ATMs(per 100,000 adults) in St. Lucia?
Give a very brief answer. 93.57. In the year 2006, what is the difference between the ATMs(per 100,000 adults) in Japan and ATMs(per 100,000 adults) in Ukraine?
Provide a succinct answer. 87.4. In the year 2006, what is the difference between the ATMs(per 100,000 adults) of Kosovo and ATMs(per 100,000 adults) of St. Lucia?
Provide a succinct answer. -21.24. In the year 2006, what is the difference between the ATMs(per 100,000 adults) in Kosovo and ATMs(per 100,000 adults) in Ukraine?
Offer a very short reply. -27.42. In the year 2006, what is the difference between the ATMs(per 100,000 adults) in St. Lucia and ATMs(per 100,000 adults) in Ukraine?
Your response must be concise. -6.18. In the year 2007, what is the difference between the ATMs(per 100,000 adults) of Japan and ATMs(per 100,000 adults) of Kosovo?
Your response must be concise. 112.79. In the year 2007, what is the difference between the ATMs(per 100,000 adults) of Japan and ATMs(per 100,000 adults) of St. Lucia?
Your answer should be compact. 92.09. In the year 2007, what is the difference between the ATMs(per 100,000 adults) of Japan and ATMs(per 100,000 adults) of Ukraine?
Offer a terse response. 72.74. In the year 2007, what is the difference between the ATMs(per 100,000 adults) of Kosovo and ATMs(per 100,000 adults) of St. Lucia?
Provide a succinct answer. -20.71. In the year 2007, what is the difference between the ATMs(per 100,000 adults) in Kosovo and ATMs(per 100,000 adults) in Ukraine?
Your answer should be very brief. -40.06. In the year 2007, what is the difference between the ATMs(per 100,000 adults) of St. Lucia and ATMs(per 100,000 adults) of Ukraine?
Offer a very short reply. -19.35. In the year 2008, what is the difference between the ATMs(per 100,000 adults) in Japan and ATMs(per 100,000 adults) in Kosovo?
Offer a very short reply. 106.46. In the year 2008, what is the difference between the ATMs(per 100,000 adults) of Japan and ATMs(per 100,000 adults) of St. Lucia?
Offer a terse response. 93.14. In the year 2008, what is the difference between the ATMs(per 100,000 adults) in Japan and ATMs(per 100,000 adults) in Ukraine?
Your answer should be compact. 55.15. In the year 2008, what is the difference between the ATMs(per 100,000 adults) in Kosovo and ATMs(per 100,000 adults) in St. Lucia?
Provide a succinct answer. -13.32. In the year 2008, what is the difference between the ATMs(per 100,000 adults) in Kosovo and ATMs(per 100,000 adults) in Ukraine?
Your response must be concise. -51.31. In the year 2008, what is the difference between the ATMs(per 100,000 adults) of St. Lucia and ATMs(per 100,000 adults) of Ukraine?
Your answer should be compact. -37.99. In the year 2009, what is the difference between the ATMs(per 100,000 adults) in Japan and ATMs(per 100,000 adults) in Kosovo?
Ensure brevity in your answer.  106.2. In the year 2009, what is the difference between the ATMs(per 100,000 adults) of Japan and ATMs(per 100,000 adults) of St. Lucia?
Provide a short and direct response. 102.71. In the year 2009, what is the difference between the ATMs(per 100,000 adults) of Japan and ATMs(per 100,000 adults) of Ukraine?
Give a very brief answer. 59.76. In the year 2009, what is the difference between the ATMs(per 100,000 adults) of Kosovo and ATMs(per 100,000 adults) of St. Lucia?
Offer a very short reply. -3.48. In the year 2009, what is the difference between the ATMs(per 100,000 adults) in Kosovo and ATMs(per 100,000 adults) in Ukraine?
Your answer should be compact. -46.44. In the year 2009, what is the difference between the ATMs(per 100,000 adults) in St. Lucia and ATMs(per 100,000 adults) in Ukraine?
Give a very brief answer. -42.96. In the year 2010, what is the difference between the ATMs(per 100,000 adults) in Japan and ATMs(per 100,000 adults) in Kosovo?
Keep it short and to the point. 98.62. In the year 2010, what is the difference between the ATMs(per 100,000 adults) of Japan and ATMs(per 100,000 adults) of St. Lucia?
Offer a very short reply. 86.33. In the year 2010, what is the difference between the ATMs(per 100,000 adults) of Japan and ATMs(per 100,000 adults) of Ukraine?
Offer a terse response. 54.46. In the year 2010, what is the difference between the ATMs(per 100,000 adults) in Kosovo and ATMs(per 100,000 adults) in St. Lucia?
Offer a terse response. -12.29. In the year 2010, what is the difference between the ATMs(per 100,000 adults) of Kosovo and ATMs(per 100,000 adults) of Ukraine?
Your answer should be compact. -44.17. In the year 2010, what is the difference between the ATMs(per 100,000 adults) in St. Lucia and ATMs(per 100,000 adults) in Ukraine?
Provide a short and direct response. -31.87. In the year 2011, what is the difference between the ATMs(per 100,000 adults) in Japan and ATMs(per 100,000 adults) in Kosovo?
Your answer should be very brief. 93.05. In the year 2011, what is the difference between the ATMs(per 100,000 adults) of Japan and ATMs(per 100,000 adults) of St. Lucia?
Keep it short and to the point. 82.47. In the year 2011, what is the difference between the ATMs(per 100,000 adults) of Japan and ATMs(per 100,000 adults) of Ukraine?
Provide a succinct answer. 44.49. In the year 2011, what is the difference between the ATMs(per 100,000 adults) in Kosovo and ATMs(per 100,000 adults) in St. Lucia?
Make the answer very short. -10.58. In the year 2011, what is the difference between the ATMs(per 100,000 adults) in Kosovo and ATMs(per 100,000 adults) in Ukraine?
Ensure brevity in your answer.  -48.56. In the year 2011, what is the difference between the ATMs(per 100,000 adults) in St. Lucia and ATMs(per 100,000 adults) in Ukraine?
Your response must be concise. -37.98. In the year 2012, what is the difference between the ATMs(per 100,000 adults) in Japan and ATMs(per 100,000 adults) in Kosovo?
Ensure brevity in your answer.  90.92. In the year 2012, what is the difference between the ATMs(per 100,000 adults) in Japan and ATMs(per 100,000 adults) in St. Lucia?
Provide a short and direct response. 81.04. In the year 2012, what is the difference between the ATMs(per 100,000 adults) of Japan and ATMs(per 100,000 adults) of Ukraine?
Offer a very short reply. 35.4. In the year 2012, what is the difference between the ATMs(per 100,000 adults) in Kosovo and ATMs(per 100,000 adults) in St. Lucia?
Make the answer very short. -9.88. In the year 2012, what is the difference between the ATMs(per 100,000 adults) of Kosovo and ATMs(per 100,000 adults) of Ukraine?
Ensure brevity in your answer.  -55.53. In the year 2012, what is the difference between the ATMs(per 100,000 adults) in St. Lucia and ATMs(per 100,000 adults) in Ukraine?
Provide a short and direct response. -45.65. In the year 2013, what is the difference between the ATMs(per 100,000 adults) of Japan and ATMs(per 100,000 adults) of Kosovo?
Your response must be concise. 90.67. In the year 2013, what is the difference between the ATMs(per 100,000 adults) of Japan and ATMs(per 100,000 adults) of St. Lucia?
Give a very brief answer. 82.08. In the year 2013, what is the difference between the ATMs(per 100,000 adults) of Japan and ATMs(per 100,000 adults) of Ukraine?
Provide a short and direct response. 24.56. In the year 2013, what is the difference between the ATMs(per 100,000 adults) of Kosovo and ATMs(per 100,000 adults) of St. Lucia?
Offer a terse response. -8.59. In the year 2013, what is the difference between the ATMs(per 100,000 adults) in Kosovo and ATMs(per 100,000 adults) in Ukraine?
Make the answer very short. -66.11. In the year 2013, what is the difference between the ATMs(per 100,000 adults) of St. Lucia and ATMs(per 100,000 adults) of Ukraine?
Provide a short and direct response. -57.52. What is the ratio of the ATMs(per 100,000 adults) in Kosovo in 2006 to that in 2007?
Make the answer very short. 0.75. What is the ratio of the ATMs(per 100,000 adults) of St. Lucia in 2006 to that in 2007?
Offer a very short reply. 0.92. What is the ratio of the ATMs(per 100,000 adults) in Ukraine in 2006 to that in 2007?
Give a very brief answer. 0.7. What is the ratio of the ATMs(per 100,000 adults) of Kosovo in 2006 to that in 2008?
Give a very brief answer. 0.49. What is the ratio of the ATMs(per 100,000 adults) of St. Lucia in 2006 to that in 2008?
Make the answer very short. 0.95. What is the ratio of the ATMs(per 100,000 adults) of Ukraine in 2006 to that in 2008?
Ensure brevity in your answer.  0.52. What is the ratio of the ATMs(per 100,000 adults) in Japan in 2006 to that in 2009?
Make the answer very short. 0.94. What is the ratio of the ATMs(per 100,000 adults) in Kosovo in 2006 to that in 2009?
Provide a succinct answer. 0.35. What is the ratio of the ATMs(per 100,000 adults) of St. Lucia in 2006 to that in 2009?
Offer a terse response. 1.02. What is the ratio of the ATMs(per 100,000 adults) of Ukraine in 2006 to that in 2009?
Provide a short and direct response. 0.5. What is the ratio of the ATMs(per 100,000 adults) in Japan in 2006 to that in 2010?
Your answer should be very brief. 0.95. What is the ratio of the ATMs(per 100,000 adults) of Kosovo in 2006 to that in 2010?
Provide a short and direct response. 0.29. What is the ratio of the ATMs(per 100,000 adults) of St. Lucia in 2006 to that in 2010?
Offer a terse response. 0.69. What is the ratio of the ATMs(per 100,000 adults) in Ukraine in 2006 to that in 2010?
Offer a terse response. 0.48. What is the ratio of the ATMs(per 100,000 adults) in Japan in 2006 to that in 2011?
Your answer should be very brief. 0.97. What is the ratio of the ATMs(per 100,000 adults) in Kosovo in 2006 to that in 2011?
Make the answer very short. 0.26. What is the ratio of the ATMs(per 100,000 adults) in St. Lucia in 2006 to that in 2011?
Your answer should be very brief. 0.66. What is the ratio of the ATMs(per 100,000 adults) of Ukraine in 2006 to that in 2011?
Your answer should be compact. 0.44. What is the ratio of the ATMs(per 100,000 adults) in Japan in 2006 to that in 2012?
Make the answer very short. 0.97. What is the ratio of the ATMs(per 100,000 adults) of Kosovo in 2006 to that in 2012?
Give a very brief answer. 0.25. What is the ratio of the ATMs(per 100,000 adults) of St. Lucia in 2006 to that in 2012?
Provide a short and direct response. 0.65. What is the ratio of the ATMs(per 100,000 adults) of Ukraine in 2006 to that in 2012?
Offer a very short reply. 0.4. What is the ratio of the ATMs(per 100,000 adults) of Japan in 2006 to that in 2013?
Make the answer very short. 0.97. What is the ratio of the ATMs(per 100,000 adults) in Kosovo in 2006 to that in 2013?
Offer a terse response. 0.25. What is the ratio of the ATMs(per 100,000 adults) of St. Lucia in 2006 to that in 2013?
Give a very brief answer. 0.66. What is the ratio of the ATMs(per 100,000 adults) of Ukraine in 2006 to that in 2013?
Keep it short and to the point. 0.35. What is the ratio of the ATMs(per 100,000 adults) in Kosovo in 2007 to that in 2008?
Make the answer very short. 0.65. What is the ratio of the ATMs(per 100,000 adults) in St. Lucia in 2007 to that in 2008?
Offer a very short reply. 1.02. What is the ratio of the ATMs(per 100,000 adults) in Ukraine in 2007 to that in 2008?
Give a very brief answer. 0.75. What is the ratio of the ATMs(per 100,000 adults) of Japan in 2007 to that in 2009?
Your answer should be very brief. 0.94. What is the ratio of the ATMs(per 100,000 adults) in Kosovo in 2007 to that in 2009?
Your answer should be compact. 0.46. What is the ratio of the ATMs(per 100,000 adults) in St. Lucia in 2007 to that in 2009?
Provide a short and direct response. 1.1. What is the ratio of the ATMs(per 100,000 adults) of Ukraine in 2007 to that in 2009?
Keep it short and to the point. 0.72. What is the ratio of the ATMs(per 100,000 adults) in Japan in 2007 to that in 2010?
Offer a very short reply. 0.96. What is the ratio of the ATMs(per 100,000 adults) of Kosovo in 2007 to that in 2010?
Your response must be concise. 0.38. What is the ratio of the ATMs(per 100,000 adults) in St. Lucia in 2007 to that in 2010?
Offer a very short reply. 0.74. What is the ratio of the ATMs(per 100,000 adults) in Ukraine in 2007 to that in 2010?
Offer a terse response. 0.69. What is the ratio of the ATMs(per 100,000 adults) of Japan in 2007 to that in 2011?
Provide a short and direct response. 0.97. What is the ratio of the ATMs(per 100,000 adults) of Kosovo in 2007 to that in 2011?
Make the answer very short. 0.35. What is the ratio of the ATMs(per 100,000 adults) of St. Lucia in 2007 to that in 2011?
Offer a terse response. 0.72. What is the ratio of the ATMs(per 100,000 adults) of Ukraine in 2007 to that in 2011?
Provide a short and direct response. 0.62. What is the ratio of the ATMs(per 100,000 adults) in Japan in 2007 to that in 2012?
Offer a terse response. 0.98. What is the ratio of the ATMs(per 100,000 adults) in Kosovo in 2007 to that in 2012?
Provide a succinct answer. 0.33. What is the ratio of the ATMs(per 100,000 adults) in St. Lucia in 2007 to that in 2012?
Keep it short and to the point. 0.71. What is the ratio of the ATMs(per 100,000 adults) in Ukraine in 2007 to that in 2012?
Your response must be concise. 0.57. What is the ratio of the ATMs(per 100,000 adults) of Japan in 2007 to that in 2013?
Keep it short and to the point. 0.98. What is the ratio of the ATMs(per 100,000 adults) in Kosovo in 2007 to that in 2013?
Your response must be concise. 0.33. What is the ratio of the ATMs(per 100,000 adults) in St. Lucia in 2007 to that in 2013?
Keep it short and to the point. 0.72. What is the ratio of the ATMs(per 100,000 adults) of Ukraine in 2007 to that in 2013?
Your response must be concise. 0.51. What is the ratio of the ATMs(per 100,000 adults) in Japan in 2008 to that in 2009?
Your response must be concise. 0.94. What is the ratio of the ATMs(per 100,000 adults) of Kosovo in 2008 to that in 2009?
Your answer should be very brief. 0.71. What is the ratio of the ATMs(per 100,000 adults) of St. Lucia in 2008 to that in 2009?
Offer a very short reply. 1.07. What is the ratio of the ATMs(per 100,000 adults) in Ukraine in 2008 to that in 2009?
Keep it short and to the point. 0.96. What is the ratio of the ATMs(per 100,000 adults) of Japan in 2008 to that in 2010?
Your answer should be compact. 0.96. What is the ratio of the ATMs(per 100,000 adults) of Kosovo in 2008 to that in 2010?
Make the answer very short. 0.59. What is the ratio of the ATMs(per 100,000 adults) in St. Lucia in 2008 to that in 2010?
Your answer should be compact. 0.72. What is the ratio of the ATMs(per 100,000 adults) of Ukraine in 2008 to that in 2010?
Keep it short and to the point. 0.92. What is the ratio of the ATMs(per 100,000 adults) of Japan in 2008 to that in 2011?
Keep it short and to the point. 0.98. What is the ratio of the ATMs(per 100,000 adults) of Kosovo in 2008 to that in 2011?
Your answer should be compact. 0.53. What is the ratio of the ATMs(per 100,000 adults) in St. Lucia in 2008 to that in 2011?
Provide a succinct answer. 0.7. What is the ratio of the ATMs(per 100,000 adults) of Ukraine in 2008 to that in 2011?
Your answer should be very brief. 0.84. What is the ratio of the ATMs(per 100,000 adults) of Japan in 2008 to that in 2012?
Offer a very short reply. 0.98. What is the ratio of the ATMs(per 100,000 adults) in Kosovo in 2008 to that in 2012?
Offer a terse response. 0.51. What is the ratio of the ATMs(per 100,000 adults) of St. Lucia in 2008 to that in 2012?
Keep it short and to the point. 0.69. What is the ratio of the ATMs(per 100,000 adults) of Ukraine in 2008 to that in 2012?
Ensure brevity in your answer.  0.76. What is the ratio of the ATMs(per 100,000 adults) of Japan in 2008 to that in 2013?
Your answer should be very brief. 0.98. What is the ratio of the ATMs(per 100,000 adults) of Kosovo in 2008 to that in 2013?
Your answer should be very brief. 0.5. What is the ratio of the ATMs(per 100,000 adults) of St. Lucia in 2008 to that in 2013?
Your response must be concise. 0.7. What is the ratio of the ATMs(per 100,000 adults) of Ukraine in 2008 to that in 2013?
Offer a very short reply. 0.68. What is the ratio of the ATMs(per 100,000 adults) of Japan in 2009 to that in 2010?
Your answer should be very brief. 1.01. What is the ratio of the ATMs(per 100,000 adults) of Kosovo in 2009 to that in 2010?
Offer a terse response. 0.82. What is the ratio of the ATMs(per 100,000 adults) in St. Lucia in 2009 to that in 2010?
Provide a short and direct response. 0.67. What is the ratio of the ATMs(per 100,000 adults) in Ukraine in 2009 to that in 2010?
Provide a short and direct response. 0.96. What is the ratio of the ATMs(per 100,000 adults) in Japan in 2009 to that in 2011?
Offer a very short reply. 1.03. What is the ratio of the ATMs(per 100,000 adults) of Kosovo in 2009 to that in 2011?
Keep it short and to the point. 0.75. What is the ratio of the ATMs(per 100,000 adults) in St. Lucia in 2009 to that in 2011?
Keep it short and to the point. 0.65. What is the ratio of the ATMs(per 100,000 adults) in Ukraine in 2009 to that in 2011?
Your response must be concise. 0.87. What is the ratio of the ATMs(per 100,000 adults) in Japan in 2009 to that in 2012?
Offer a very short reply. 1.04. What is the ratio of the ATMs(per 100,000 adults) of Kosovo in 2009 to that in 2012?
Your answer should be very brief. 0.72. What is the ratio of the ATMs(per 100,000 adults) in St. Lucia in 2009 to that in 2012?
Your answer should be very brief. 0.64. What is the ratio of the ATMs(per 100,000 adults) in Ukraine in 2009 to that in 2012?
Keep it short and to the point. 0.79. What is the ratio of the ATMs(per 100,000 adults) in Japan in 2009 to that in 2013?
Ensure brevity in your answer.  1.03. What is the ratio of the ATMs(per 100,000 adults) in Kosovo in 2009 to that in 2013?
Give a very brief answer. 0.71. What is the ratio of the ATMs(per 100,000 adults) of St. Lucia in 2009 to that in 2013?
Give a very brief answer. 0.65. What is the ratio of the ATMs(per 100,000 adults) in Ukraine in 2009 to that in 2013?
Provide a short and direct response. 0.7. What is the ratio of the ATMs(per 100,000 adults) in Japan in 2010 to that in 2011?
Ensure brevity in your answer.  1.02. What is the ratio of the ATMs(per 100,000 adults) in Kosovo in 2010 to that in 2011?
Ensure brevity in your answer.  0.91. What is the ratio of the ATMs(per 100,000 adults) in St. Lucia in 2010 to that in 2011?
Make the answer very short. 0.97. What is the ratio of the ATMs(per 100,000 adults) in Ukraine in 2010 to that in 2011?
Offer a terse response. 0.91. What is the ratio of the ATMs(per 100,000 adults) of Japan in 2010 to that in 2012?
Offer a very short reply. 1.02. What is the ratio of the ATMs(per 100,000 adults) of Kosovo in 2010 to that in 2012?
Ensure brevity in your answer.  0.87. What is the ratio of the ATMs(per 100,000 adults) of St. Lucia in 2010 to that in 2012?
Offer a terse response. 0.95. What is the ratio of the ATMs(per 100,000 adults) in Ukraine in 2010 to that in 2012?
Keep it short and to the point. 0.83. What is the ratio of the ATMs(per 100,000 adults) of Kosovo in 2010 to that in 2013?
Make the answer very short. 0.86. What is the ratio of the ATMs(per 100,000 adults) of St. Lucia in 2010 to that in 2013?
Offer a terse response. 0.96. What is the ratio of the ATMs(per 100,000 adults) in Ukraine in 2010 to that in 2013?
Ensure brevity in your answer.  0.74. What is the ratio of the ATMs(per 100,000 adults) in Kosovo in 2011 to that in 2012?
Your response must be concise. 0.96. What is the ratio of the ATMs(per 100,000 adults) of St. Lucia in 2011 to that in 2012?
Ensure brevity in your answer.  0.98. What is the ratio of the ATMs(per 100,000 adults) of Ukraine in 2011 to that in 2012?
Your answer should be very brief. 0.91. What is the ratio of the ATMs(per 100,000 adults) in Kosovo in 2011 to that in 2013?
Your response must be concise. 0.94. What is the ratio of the ATMs(per 100,000 adults) in St. Lucia in 2011 to that in 2013?
Provide a succinct answer. 1. What is the ratio of the ATMs(per 100,000 adults) in Ukraine in 2011 to that in 2013?
Offer a terse response. 0.81. What is the ratio of the ATMs(per 100,000 adults) of Kosovo in 2012 to that in 2013?
Provide a succinct answer. 0.98. What is the ratio of the ATMs(per 100,000 adults) of St. Lucia in 2012 to that in 2013?
Your answer should be very brief. 1.01. What is the ratio of the ATMs(per 100,000 adults) in Ukraine in 2012 to that in 2013?
Ensure brevity in your answer.  0.89. What is the difference between the highest and the second highest ATMs(per 100,000 adults) in Japan?
Offer a terse response. 1.89. What is the difference between the highest and the second highest ATMs(per 100,000 adults) of Kosovo?
Provide a short and direct response. 0.72. What is the difference between the highest and the second highest ATMs(per 100,000 adults) of St. Lucia?
Your answer should be compact. 0.57. What is the difference between the highest and the second highest ATMs(per 100,000 adults) in Ukraine?
Offer a terse response. 11.31. What is the difference between the highest and the lowest ATMs(per 100,000 adults) of Japan?
Ensure brevity in your answer.  8.6. What is the difference between the highest and the lowest ATMs(per 100,000 adults) in Kosovo?
Your answer should be compact. 28.29. What is the difference between the highest and the lowest ATMs(per 100,000 adults) of St. Lucia?
Your answer should be compact. 16.75. What is the difference between the highest and the lowest ATMs(per 100,000 adults) of Ukraine?
Keep it short and to the point. 66.99. 